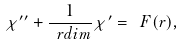Convert formula to latex. <formula><loc_0><loc_0><loc_500><loc_500>\chi ^ { \prime \prime } + { \frac { 1 } { \ r d i m } } \chi ^ { \prime } = \ F ( r ) ,</formula> 